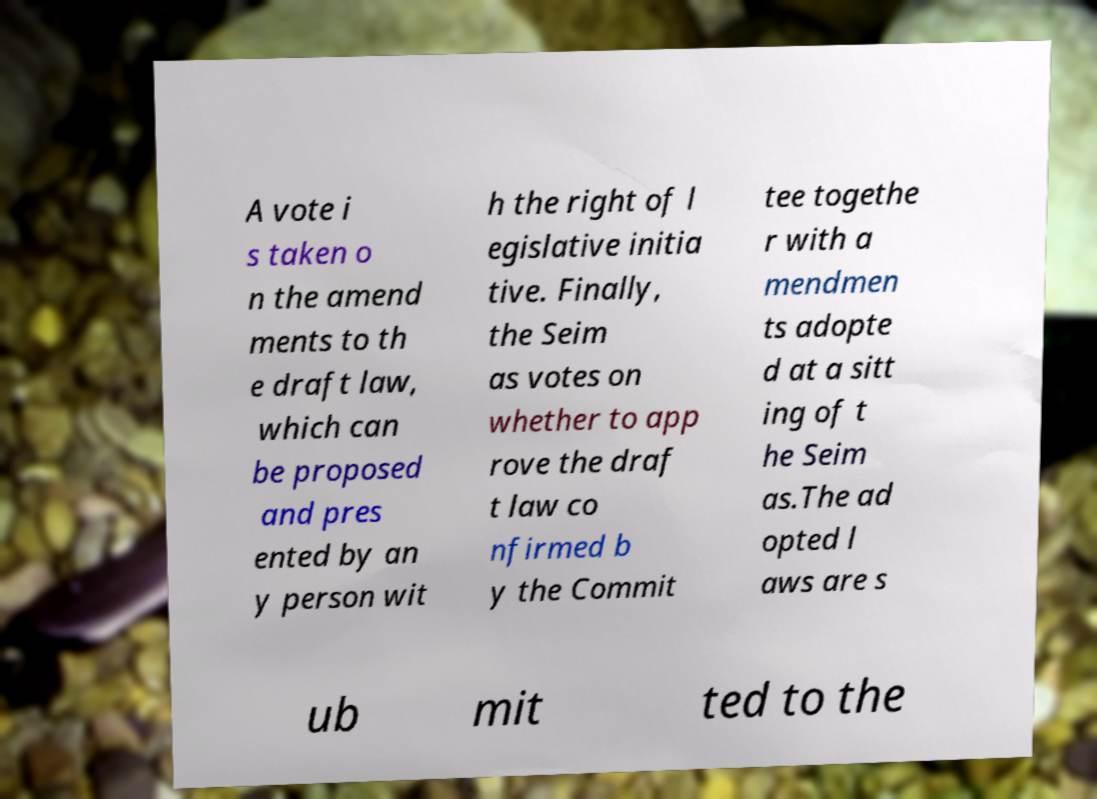Please identify and transcribe the text found in this image. A vote i s taken o n the amend ments to th e draft law, which can be proposed and pres ented by an y person wit h the right of l egislative initia tive. Finally, the Seim as votes on whether to app rove the draf t law co nfirmed b y the Commit tee togethe r with a mendmen ts adopte d at a sitt ing of t he Seim as.The ad opted l aws are s ub mit ted to the 